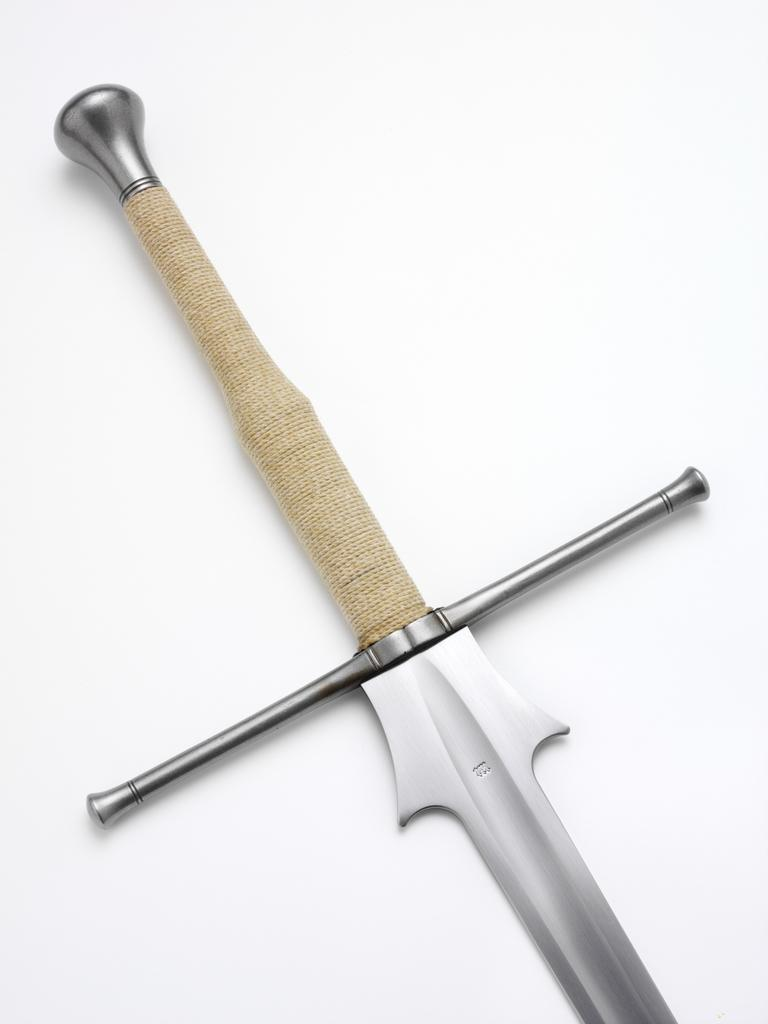What object is present on the white surface in the image? There is a knife in the image. What color is the surface on which the knife is placed? The surface is white. What type of berry is being cut by the knife in the image? There is no berry present in the image; only a knife on a white surface is visible. 